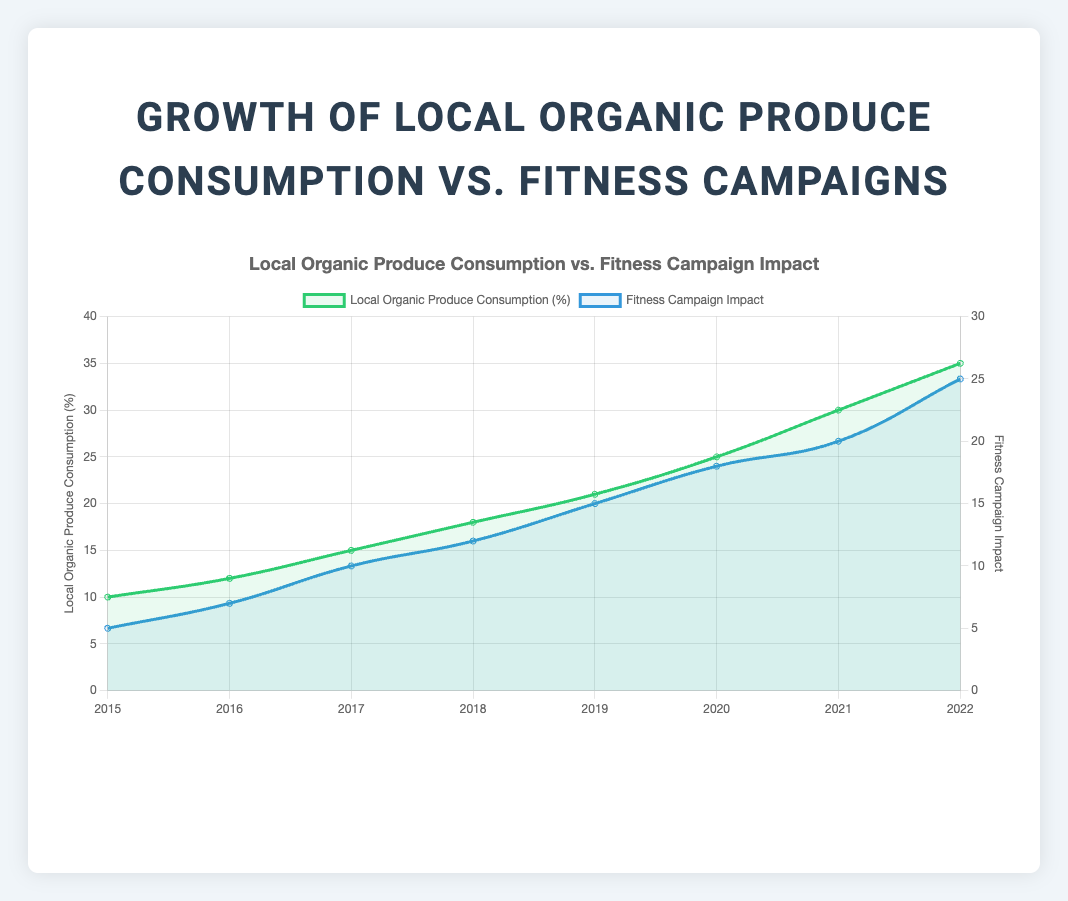How has local organic produce consumption changed from 2015 to 2022? To determine the change in local organic produce consumption from 2015 to 2022, look at the values for those years: 10% in 2015 and 35% in 2022. Subtract the 2015 value from the 2022 value: 35% - 10% = 25%.
Answer: It increased by 25% How many fitness and health awareness campaigns had an impact factor of more than 15? Identify the campaigns with impact factors greater than 15: "Virtual Workout Marathon" (18), "Lakefront Fitness Series" (20), and "Healthy Chicago 2025" (25). Count them: 3 campaigns.
Answer: Three campaigns Which year had the highest increase in local organic produce consumption? Calculate the increase in consumption for each year: 
From 2015 to 2016: 12 - 10 = 2
From 2016 to 2017: 15 - 12 = 3
From 2017 to 2018: 18 - 15 = 3
From 2018 to 2019: 21 - 18 = 3
From 2019 to 2020: 25 - 21 = 4
From 2020 to 2021: 30 - 25 = 5
From 2021 to 2022: 35 - 30 = 5
The highest increase is from 2020 to 2021 and from 2021 to 2022, which are both 5.
Answer: 2020 to 2021 and 2021 to 2022 Which is generally more visible on the plot: the line representing local organic produce consumption or the line representing fitness campaign impact? Visually, the green line representing local organic produce consumption looks more prominent due to the higher range it covers on the y-axis (up to 40) as compared to the blue line for fitness campaign impact (up to 30).
Answer: Local organic produce consumption What was the fitness campaign in 2019, and what was its impact factor? Hover over or look at the tooltip information for 2019. The fitness campaign was "Chicago Wellness Fest" with an impact factor of 15.
Answer: Chicago Wellness Fest, 15 During which year was the impact of fitness campaigns closest to the consumption of local organic produce? Look for the closest alignment between the two lines. It appears that in 2020, both measurements are closer together with values being 25% for produce consumption and 18 for campaign impact.
Answer: 2020 What is the average annual increase in local organic produce consumption from 2015 to 2022? First, calculate the total increase: 35% (2022) - 10% (2015) = 25%. Then divide by the number of intervals (2022 - 2015 = 7 years): 25% / 7 = approximately 3.57% per year.
Answer: Approximately 3.57% per year How does the trend in the impact of fitness and health awareness campaigns correlate with the trend in local organic produce consumption? The trends appear to be positively correlated, meaning as the impact of fitness campaigns increases, the consumption of local organic produce also tends to increase. Both lines show an upward trend over the years.
Answer: They are positively correlated How much did local organic produce consumption and fitness campaign impact increase from 2019 to 2020? Calculate the increase for each metric from 2019 to 2020:
Produce consumption: 25% (2020) - 21% (2019) = 4%
Campaign impact: 18 (2020) - 15 (2019) = 3
Answer: 4% for consumption and 3 for campaign impact What color represents the line for local organic produce consumption on the plot? The line for local organic produce consumption is represented in green.
Answer: Green 